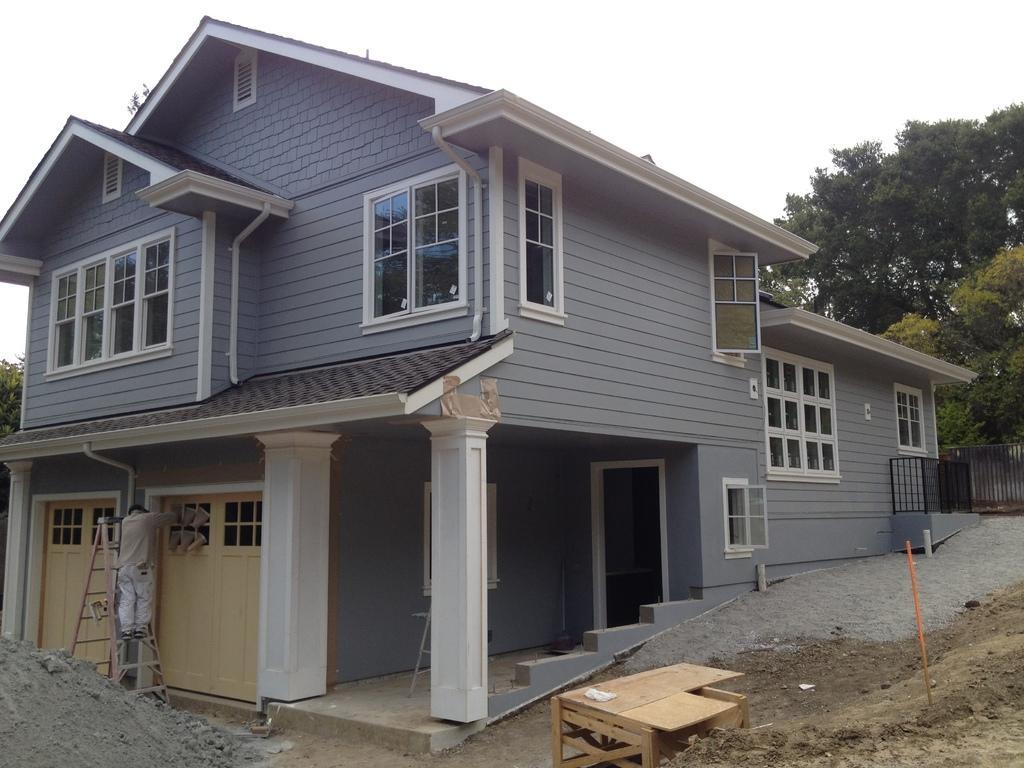Describe this image in one or two sentences. To this house there are windows and doors. Background we can see trees and fence. Beside this house there is a table. In-front of this house there is a ladder and person. 